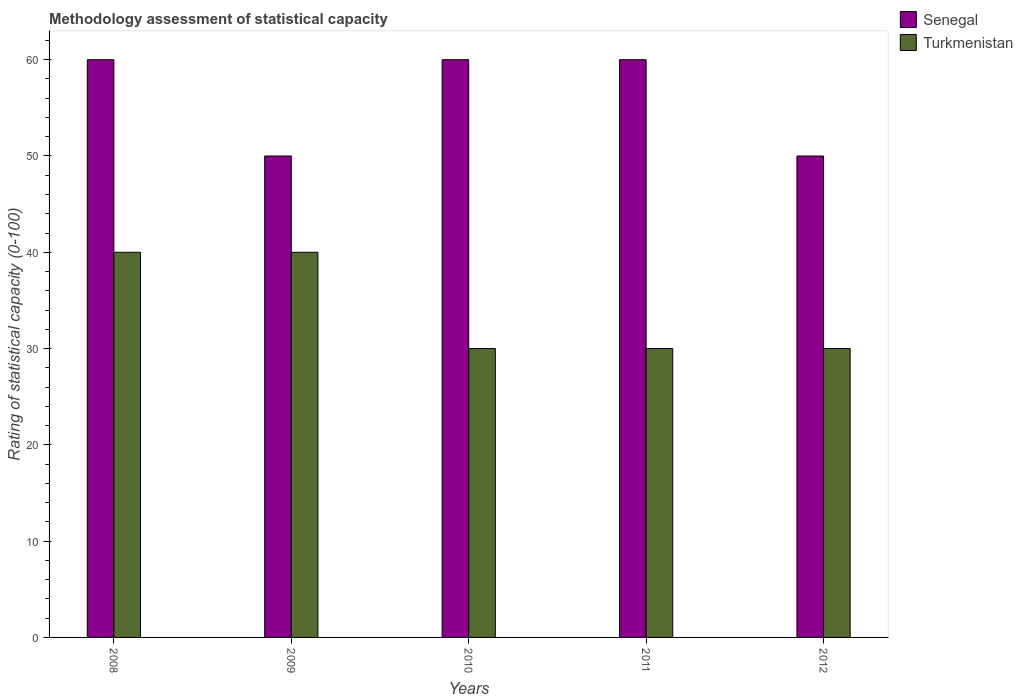How many different coloured bars are there?
Offer a terse response. 2. How many groups of bars are there?
Ensure brevity in your answer.  5. In how many cases, is the number of bars for a given year not equal to the number of legend labels?
Provide a succinct answer. 0. What is the rating of statistical capacity in Turkmenistan in 2009?
Offer a very short reply. 40. Across all years, what is the maximum rating of statistical capacity in Senegal?
Give a very brief answer. 60. Across all years, what is the minimum rating of statistical capacity in Senegal?
Ensure brevity in your answer.  50. What is the total rating of statistical capacity in Senegal in the graph?
Provide a short and direct response. 280. What is the difference between the rating of statistical capacity in Turkmenistan in 2008 and that in 2010?
Your answer should be compact. 10. What is the difference between the rating of statistical capacity in Turkmenistan in 2008 and the rating of statistical capacity in Senegal in 2009?
Offer a very short reply. -10. What is the average rating of statistical capacity in Senegal per year?
Make the answer very short. 56. In the year 2011, what is the difference between the rating of statistical capacity in Senegal and rating of statistical capacity in Turkmenistan?
Ensure brevity in your answer.  30. In how many years, is the rating of statistical capacity in Senegal greater than 12?
Provide a succinct answer. 5. What is the difference between the highest and the second highest rating of statistical capacity in Turkmenistan?
Provide a succinct answer. 0. What is the difference between the highest and the lowest rating of statistical capacity in Senegal?
Your answer should be compact. 10. In how many years, is the rating of statistical capacity in Turkmenistan greater than the average rating of statistical capacity in Turkmenistan taken over all years?
Provide a succinct answer. 2. What does the 2nd bar from the left in 2012 represents?
Your answer should be very brief. Turkmenistan. What does the 2nd bar from the right in 2010 represents?
Offer a very short reply. Senegal. Are all the bars in the graph horizontal?
Offer a terse response. No. Are the values on the major ticks of Y-axis written in scientific E-notation?
Make the answer very short. No. Does the graph contain any zero values?
Give a very brief answer. No. Does the graph contain grids?
Keep it short and to the point. No. How many legend labels are there?
Provide a short and direct response. 2. How are the legend labels stacked?
Provide a short and direct response. Vertical. What is the title of the graph?
Offer a very short reply. Methodology assessment of statistical capacity. Does "Dominican Republic" appear as one of the legend labels in the graph?
Make the answer very short. No. What is the label or title of the Y-axis?
Give a very brief answer. Rating of statistical capacity (0-100). What is the Rating of statistical capacity (0-100) in Senegal in 2008?
Your answer should be compact. 60. What is the Rating of statistical capacity (0-100) of Turkmenistan in 2008?
Your answer should be compact. 40. What is the Rating of statistical capacity (0-100) in Turkmenistan in 2009?
Give a very brief answer. 40. What is the Rating of statistical capacity (0-100) in Senegal in 2010?
Offer a very short reply. 60. What is the Rating of statistical capacity (0-100) of Turkmenistan in 2011?
Keep it short and to the point. 30. What is the Rating of statistical capacity (0-100) in Turkmenistan in 2012?
Your response must be concise. 30. Across all years, what is the maximum Rating of statistical capacity (0-100) of Turkmenistan?
Keep it short and to the point. 40. Across all years, what is the minimum Rating of statistical capacity (0-100) of Turkmenistan?
Ensure brevity in your answer.  30. What is the total Rating of statistical capacity (0-100) of Senegal in the graph?
Your response must be concise. 280. What is the total Rating of statistical capacity (0-100) of Turkmenistan in the graph?
Your answer should be compact. 170. What is the difference between the Rating of statistical capacity (0-100) in Senegal in 2008 and that in 2010?
Provide a short and direct response. 0. What is the difference between the Rating of statistical capacity (0-100) in Turkmenistan in 2008 and that in 2011?
Offer a terse response. 10. What is the difference between the Rating of statistical capacity (0-100) of Senegal in 2009 and that in 2010?
Give a very brief answer. -10. What is the difference between the Rating of statistical capacity (0-100) in Turkmenistan in 2009 and that in 2010?
Your response must be concise. 10. What is the difference between the Rating of statistical capacity (0-100) in Senegal in 2009 and that in 2011?
Ensure brevity in your answer.  -10. What is the difference between the Rating of statistical capacity (0-100) in Turkmenistan in 2009 and that in 2011?
Give a very brief answer. 10. What is the difference between the Rating of statistical capacity (0-100) in Turkmenistan in 2009 and that in 2012?
Your answer should be very brief. 10. What is the difference between the Rating of statistical capacity (0-100) of Senegal in 2010 and that in 2011?
Offer a very short reply. 0. What is the difference between the Rating of statistical capacity (0-100) of Turkmenistan in 2010 and that in 2011?
Make the answer very short. 0. What is the difference between the Rating of statistical capacity (0-100) of Senegal in 2010 and that in 2012?
Your answer should be compact. 10. What is the difference between the Rating of statistical capacity (0-100) in Senegal in 2008 and the Rating of statistical capacity (0-100) in Turkmenistan in 2009?
Your answer should be very brief. 20. What is the difference between the Rating of statistical capacity (0-100) of Senegal in 2008 and the Rating of statistical capacity (0-100) of Turkmenistan in 2010?
Give a very brief answer. 30. What is the difference between the Rating of statistical capacity (0-100) in Senegal in 2009 and the Rating of statistical capacity (0-100) in Turkmenistan in 2011?
Provide a succinct answer. 20. What is the difference between the Rating of statistical capacity (0-100) in Senegal in 2010 and the Rating of statistical capacity (0-100) in Turkmenistan in 2011?
Make the answer very short. 30. What is the difference between the Rating of statistical capacity (0-100) in Senegal in 2010 and the Rating of statistical capacity (0-100) in Turkmenistan in 2012?
Give a very brief answer. 30. What is the average Rating of statistical capacity (0-100) of Senegal per year?
Your answer should be compact. 56. What is the average Rating of statistical capacity (0-100) in Turkmenistan per year?
Keep it short and to the point. 34. In the year 2012, what is the difference between the Rating of statistical capacity (0-100) of Senegal and Rating of statistical capacity (0-100) of Turkmenistan?
Ensure brevity in your answer.  20. What is the ratio of the Rating of statistical capacity (0-100) in Senegal in 2008 to that in 2009?
Your answer should be compact. 1.2. What is the ratio of the Rating of statistical capacity (0-100) in Turkmenistan in 2008 to that in 2009?
Provide a short and direct response. 1. What is the ratio of the Rating of statistical capacity (0-100) of Turkmenistan in 2008 to that in 2012?
Ensure brevity in your answer.  1.33. What is the ratio of the Rating of statistical capacity (0-100) in Senegal in 2009 to that in 2010?
Offer a terse response. 0.83. What is the ratio of the Rating of statistical capacity (0-100) of Turkmenistan in 2009 to that in 2011?
Offer a very short reply. 1.33. What is the ratio of the Rating of statistical capacity (0-100) of Senegal in 2009 to that in 2012?
Offer a very short reply. 1. What is the ratio of the Rating of statistical capacity (0-100) of Turkmenistan in 2009 to that in 2012?
Keep it short and to the point. 1.33. What is the ratio of the Rating of statistical capacity (0-100) of Senegal in 2010 to that in 2011?
Your answer should be very brief. 1. What is the ratio of the Rating of statistical capacity (0-100) of Senegal in 2010 to that in 2012?
Provide a succinct answer. 1.2. What is the ratio of the Rating of statistical capacity (0-100) of Senegal in 2011 to that in 2012?
Give a very brief answer. 1.2. What is the ratio of the Rating of statistical capacity (0-100) of Turkmenistan in 2011 to that in 2012?
Provide a succinct answer. 1. What is the difference between the highest and the lowest Rating of statistical capacity (0-100) in Turkmenistan?
Ensure brevity in your answer.  10. 